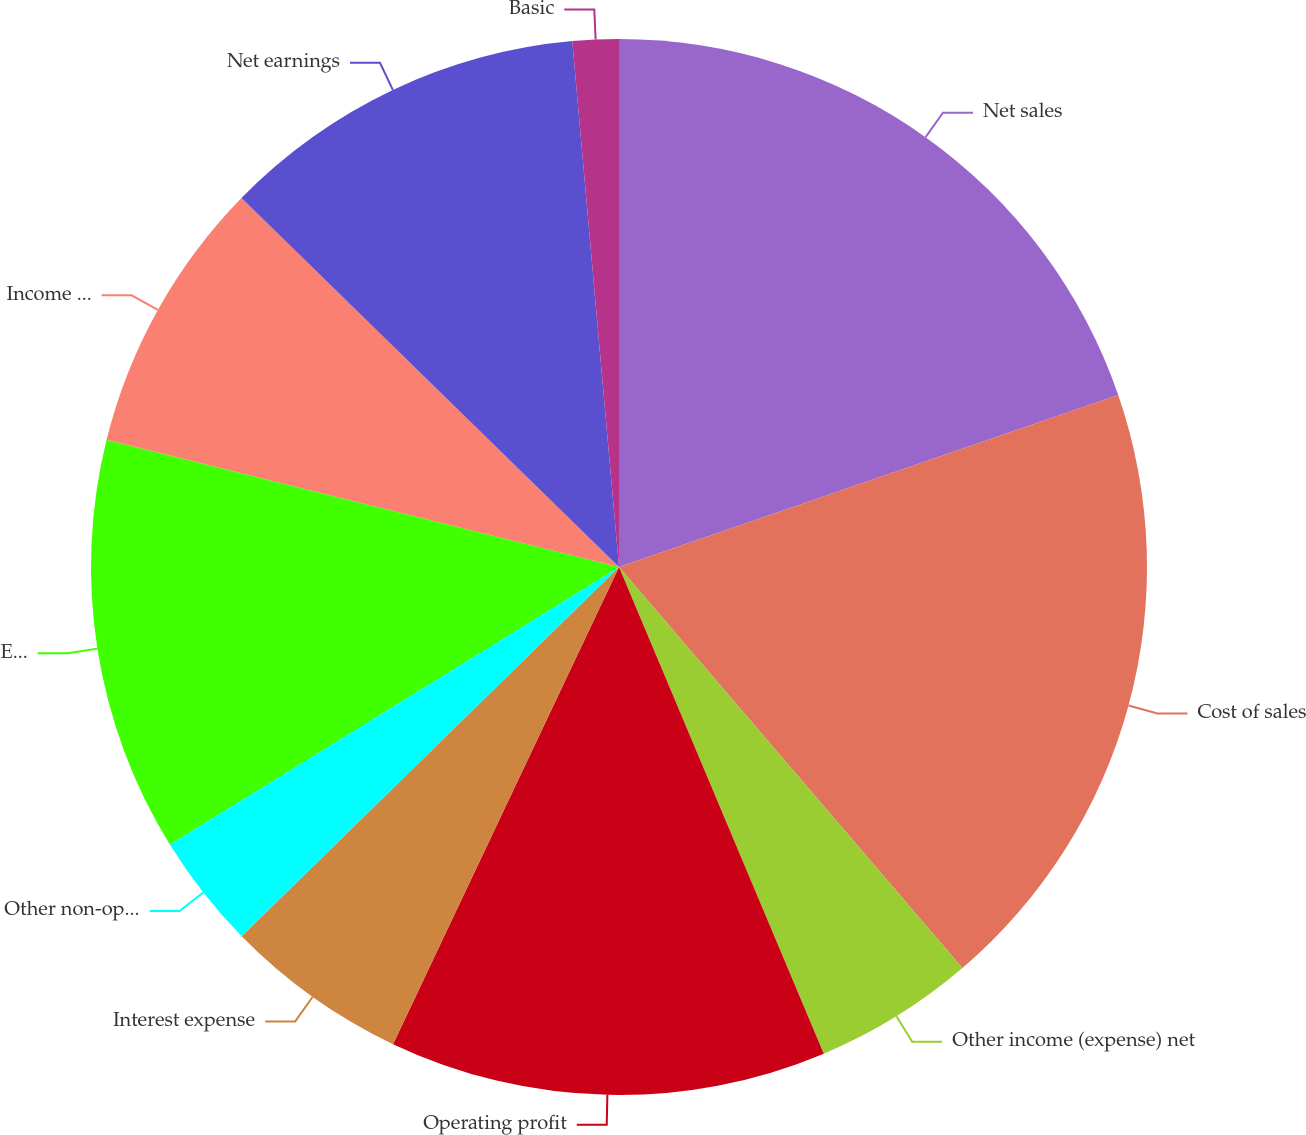Convert chart to OTSL. <chart><loc_0><loc_0><loc_500><loc_500><pie_chart><fcel>Net sales<fcel>Cost of sales<fcel>Other income (expense) net<fcel>Operating profit<fcel>Interest expense<fcel>Other non-operating income<fcel>Earnings before income taxes<fcel>Income tax expense<fcel>Net earnings<fcel>Basic<nl><fcel>19.72%<fcel>19.01%<fcel>4.93%<fcel>13.38%<fcel>5.63%<fcel>3.52%<fcel>12.68%<fcel>8.45%<fcel>11.27%<fcel>1.41%<nl></chart> 